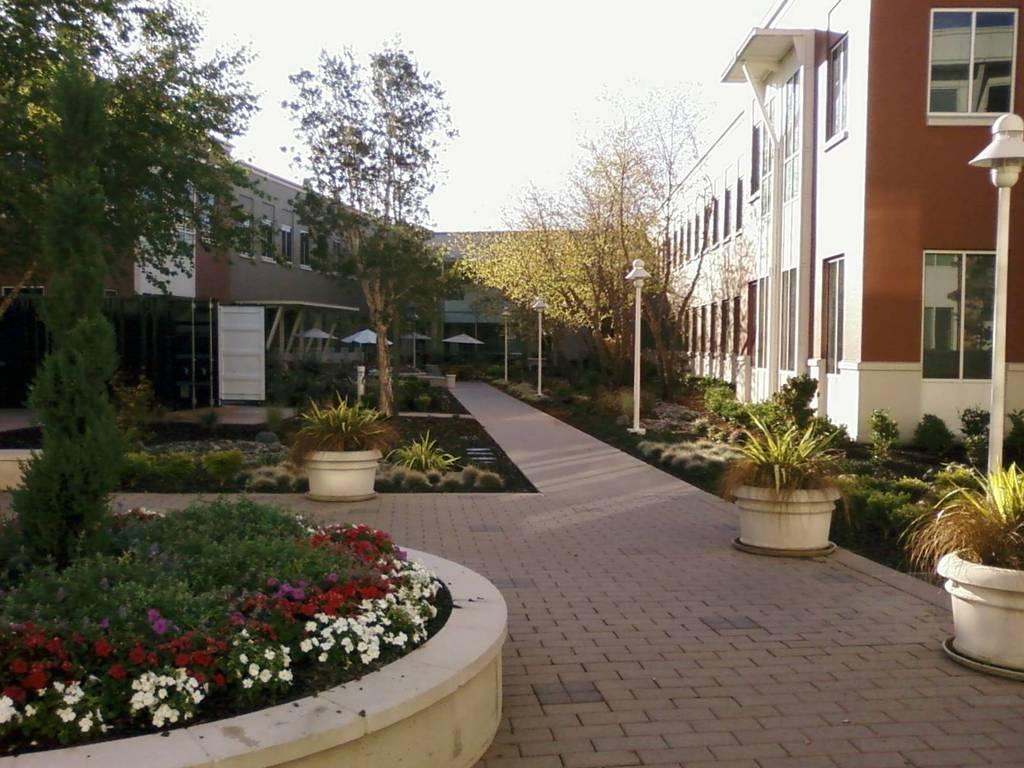In one or two sentences, can you explain what this image depicts? In this image I can see a building which is brown and white in color and I can see few plants, few flowers which are red, pink and white in color and I can see a door , few tents which are white in color, few flower pots, few white colored poles and In the background I can see the sky. 